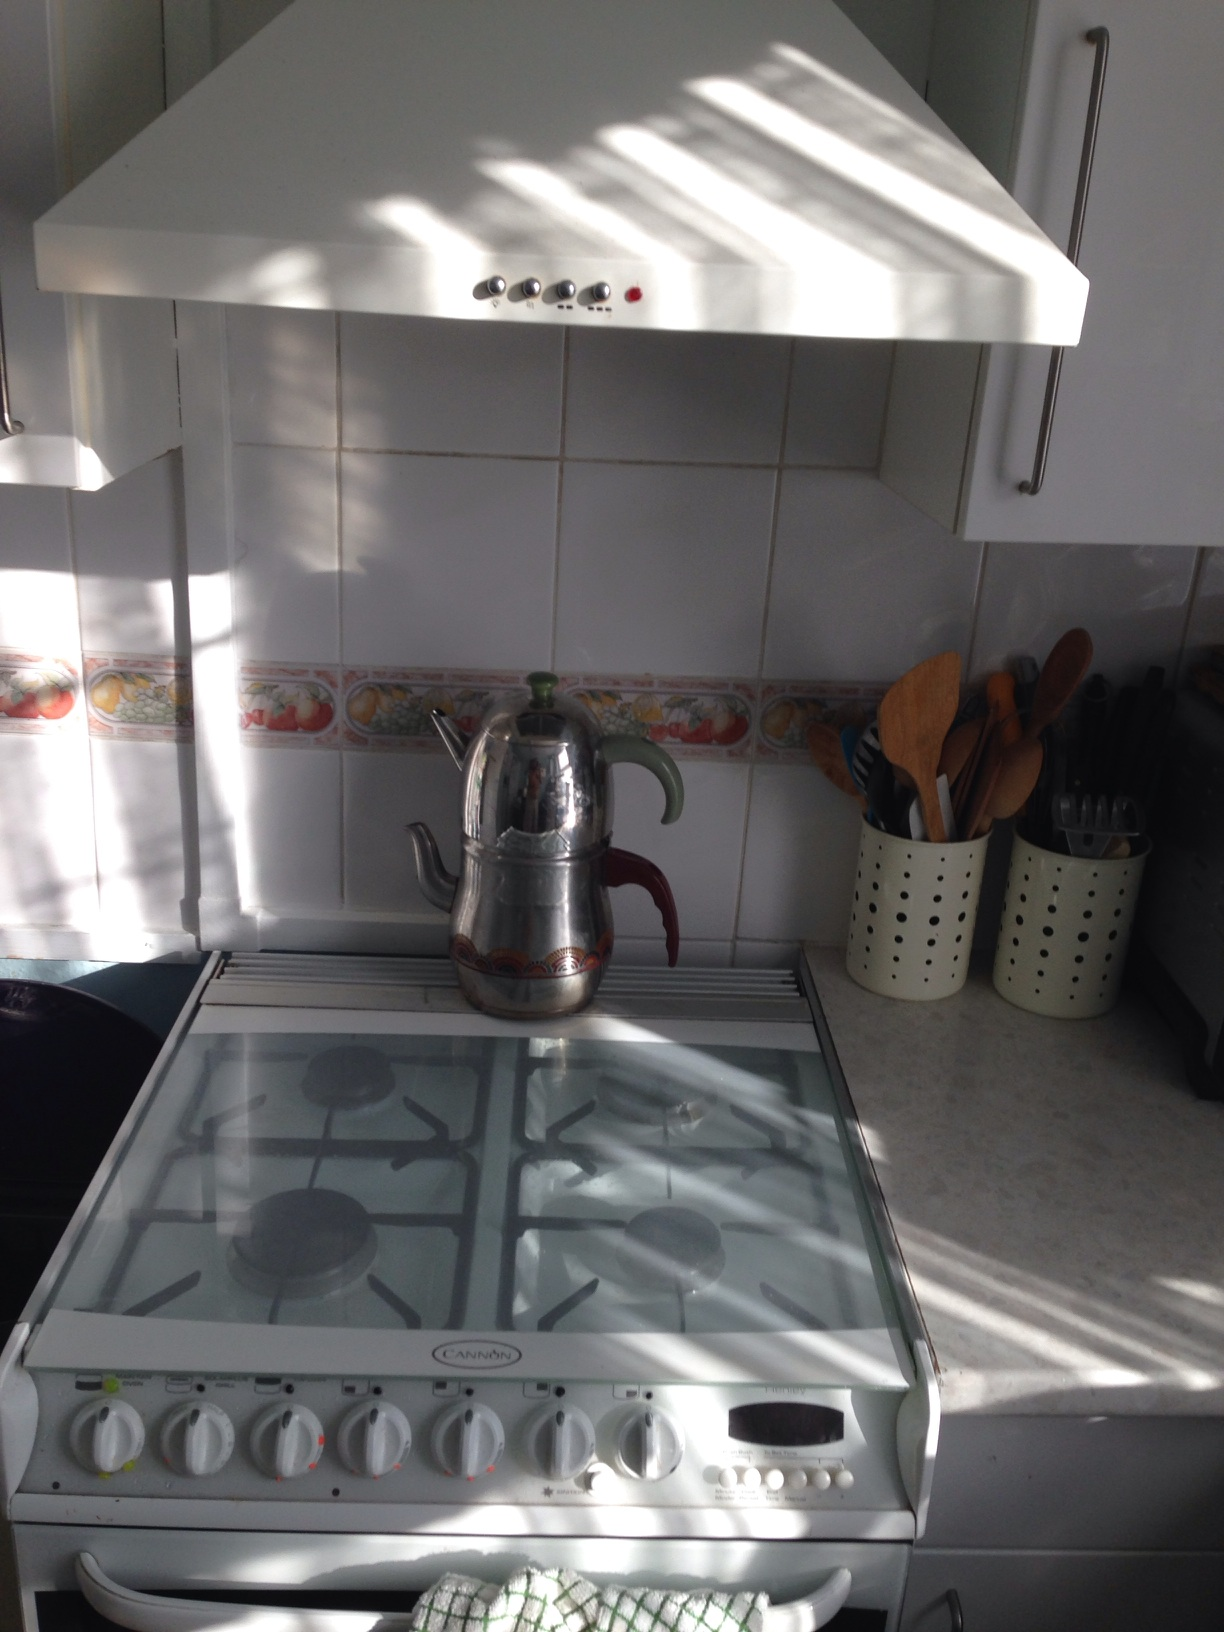Imagine the most creative recipe you can think of that could be prepared here. Imagine preparing a fantastical dish called 'Luminescent Mermaid Stew'! This unique recipe involves creating a broth using rare bioluminescent seaweed, harvested from the deepest parts of the ocean. The stew would include colorful shellfish, each glowing with a different hue, and float atop the luminous broth like vibrant stars in a night sky. To garnish, add a sprinkling of edible glitter made from ground pearl dust. The aroma would be a blend of oceanic freshness with a hint of mystical spices not found on land. This dish, prepared in such a comforting and inviting kitchen, would turn any ordinary meal into an extraordinary culinary journey! 